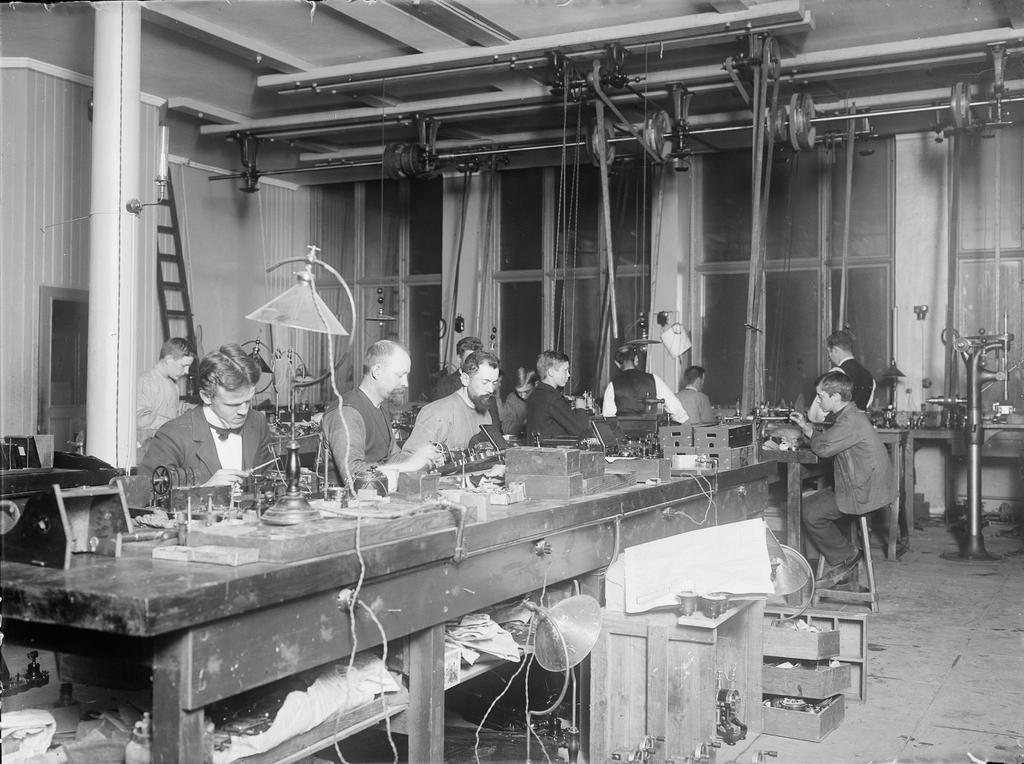Describe this image in one or two sentences. In the picture I can see people among them some are standing on the floor and some are sitting in front of tables. On tables I can see light lamp, tools and some other objects. In the background I can see windows, curtains, pole, ladder and some other objects. This picture is black and white in color. 